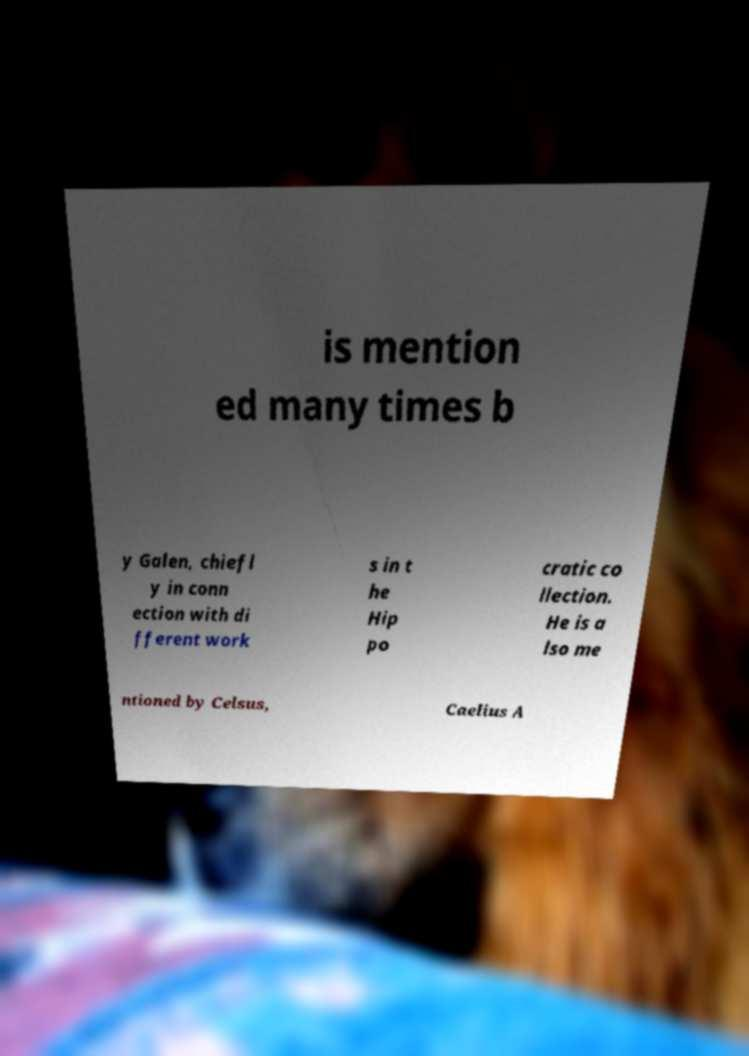Can you accurately transcribe the text from the provided image for me? is mention ed many times b y Galen, chiefl y in conn ection with di fferent work s in t he Hip po cratic co llection. He is a lso me ntioned by Celsus, Caelius A 